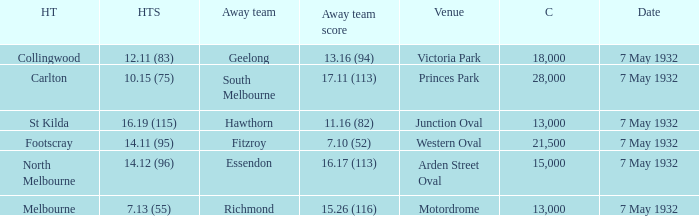Which home team is hosting hawthorn as the away team? St Kilda. 